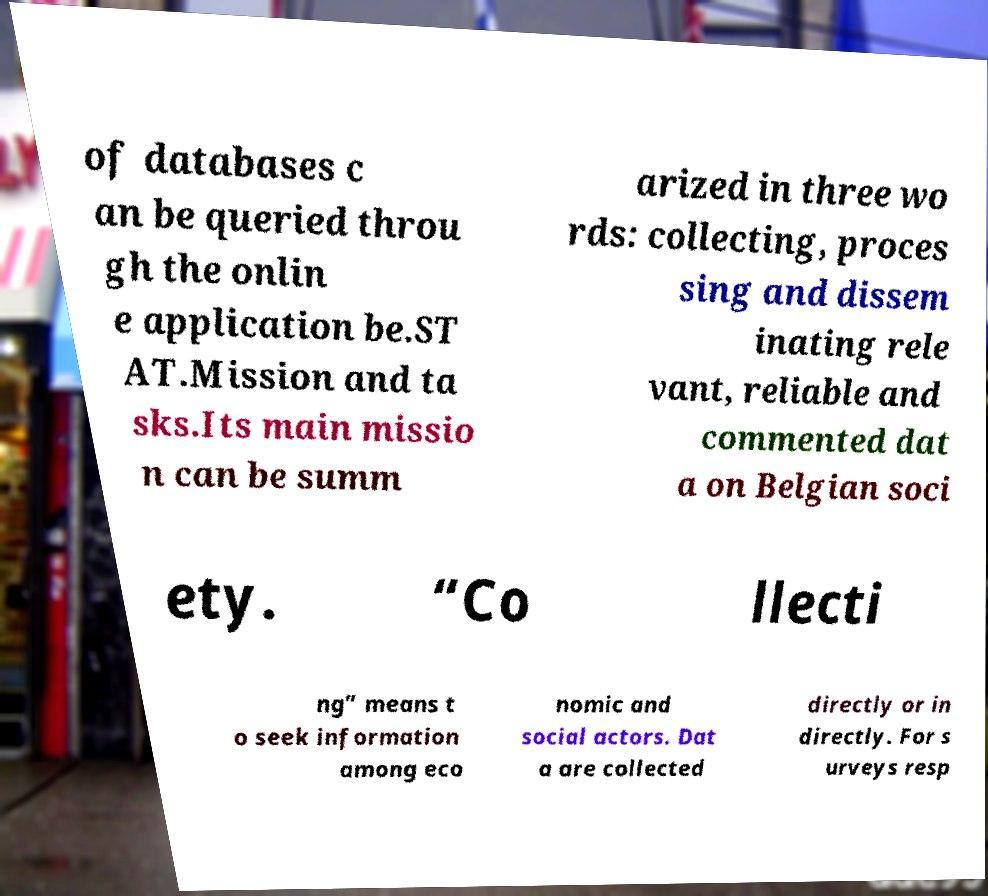Can you read and provide the text displayed in the image?This photo seems to have some interesting text. Can you extract and type it out for me? of databases c an be queried throu gh the onlin e application be.ST AT.Mission and ta sks.Its main missio n can be summ arized in three wo rds: collecting, proces sing and dissem inating rele vant, reliable and commented dat a on Belgian soci ety. “Co llecti ng” means t o seek information among eco nomic and social actors. Dat a are collected directly or in directly. For s urveys resp 